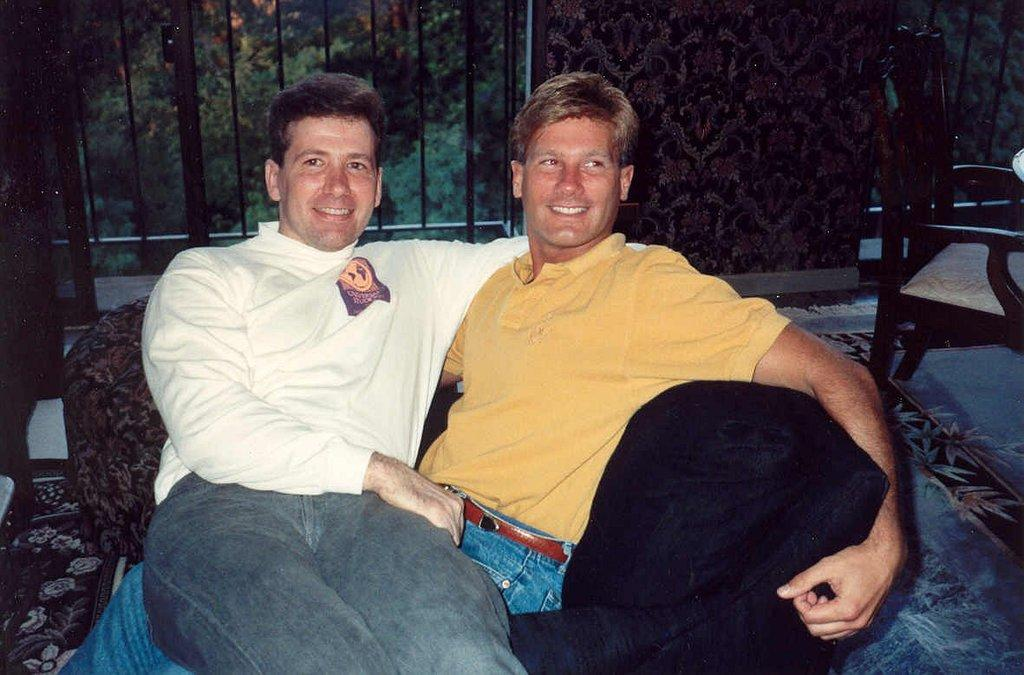How many people are in the image? There are two persons in the image. What expression do the persons have? The persons are smiling. Where are the persons sitting in the image? The persons are sitting on a sofa. What other furniture can be seen in the image? There is a chair in the image. What is visible in the background of the image? There are windows, trees, and a wall in the background of the image. Can you see a hen walking on the slope in the image? There is no hen or slope present in the image. 